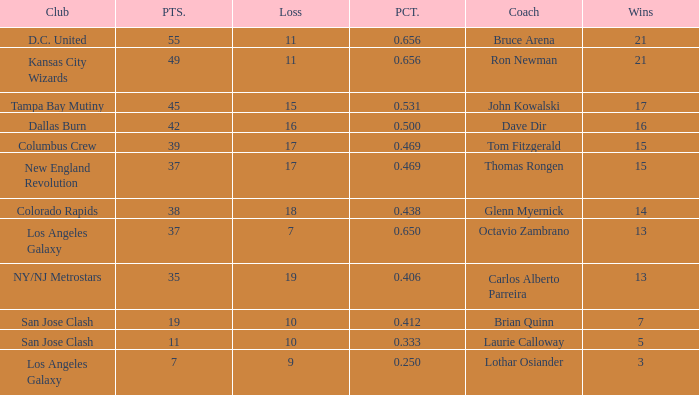What is the sum of points when Bruce Arena has 21 wins? 55.0. 